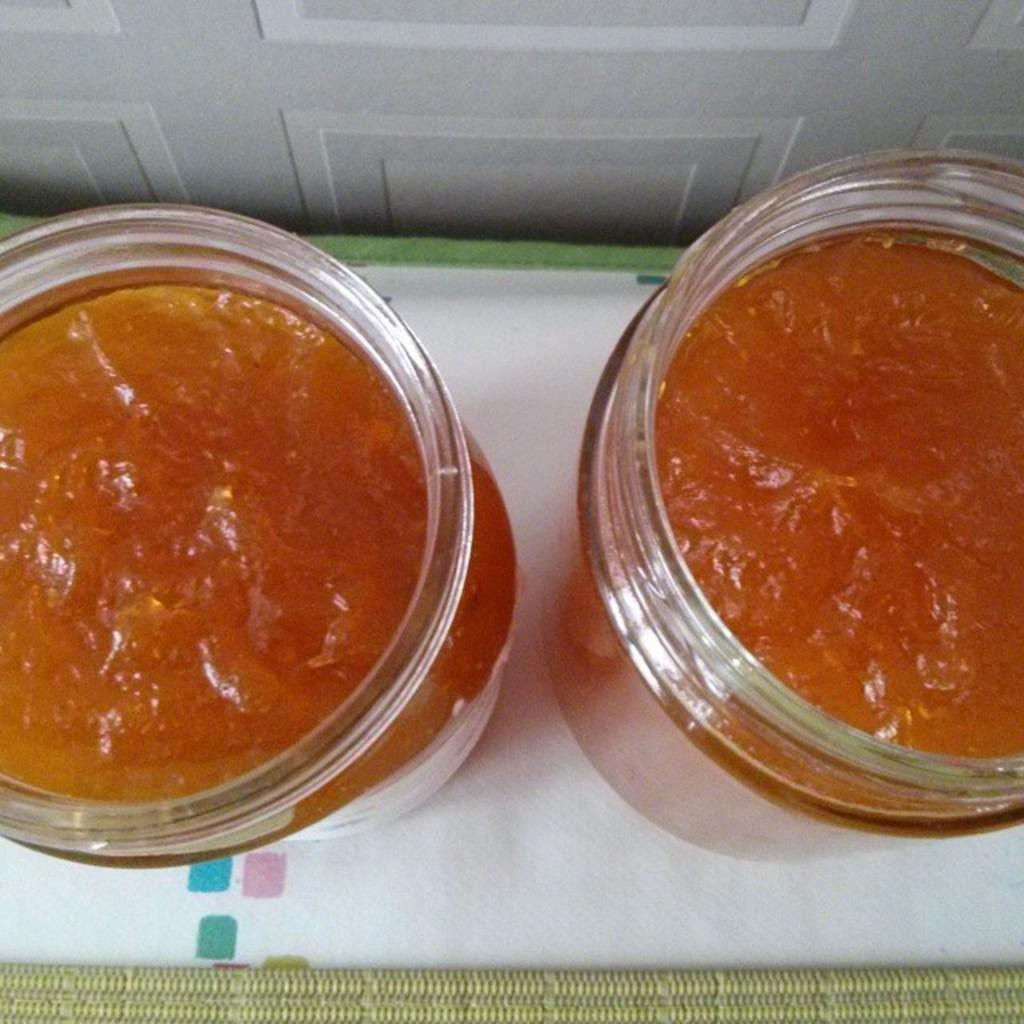What type of containers are visible in the image? There are glass jars in the image. What are the glass jars holding? The glass jars contain food items. Where are the glass jars located? The glass jars are on a surface. Can you see a tooth inside one of the glass jars? No, there is no tooth present in any of the glass jars in the image. 